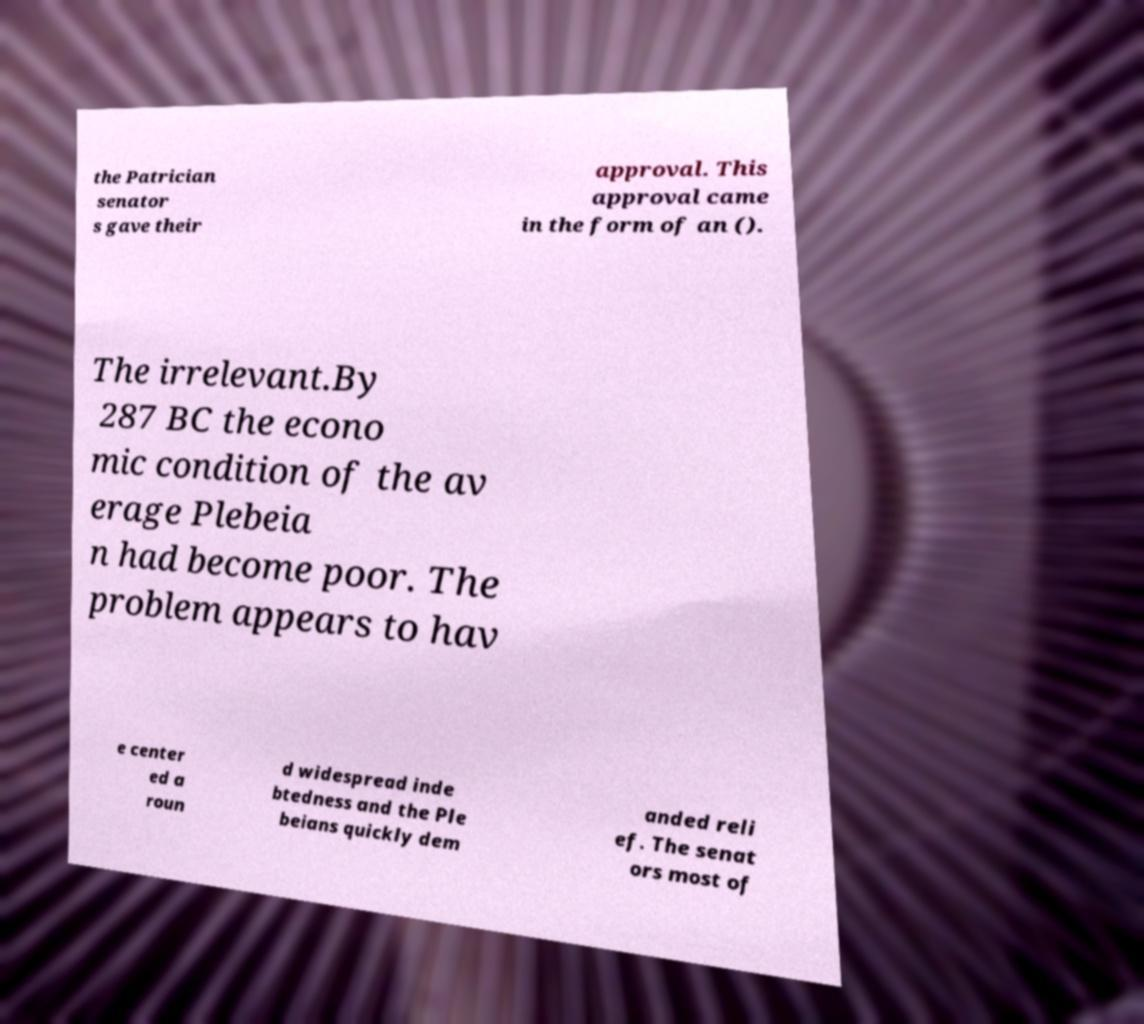Could you extract and type out the text from this image? the Patrician senator s gave their approval. This approval came in the form of an (). The irrelevant.By 287 BC the econo mic condition of the av erage Plebeia n had become poor. The problem appears to hav e center ed a roun d widespread inde btedness and the Ple beians quickly dem anded reli ef. The senat ors most of 